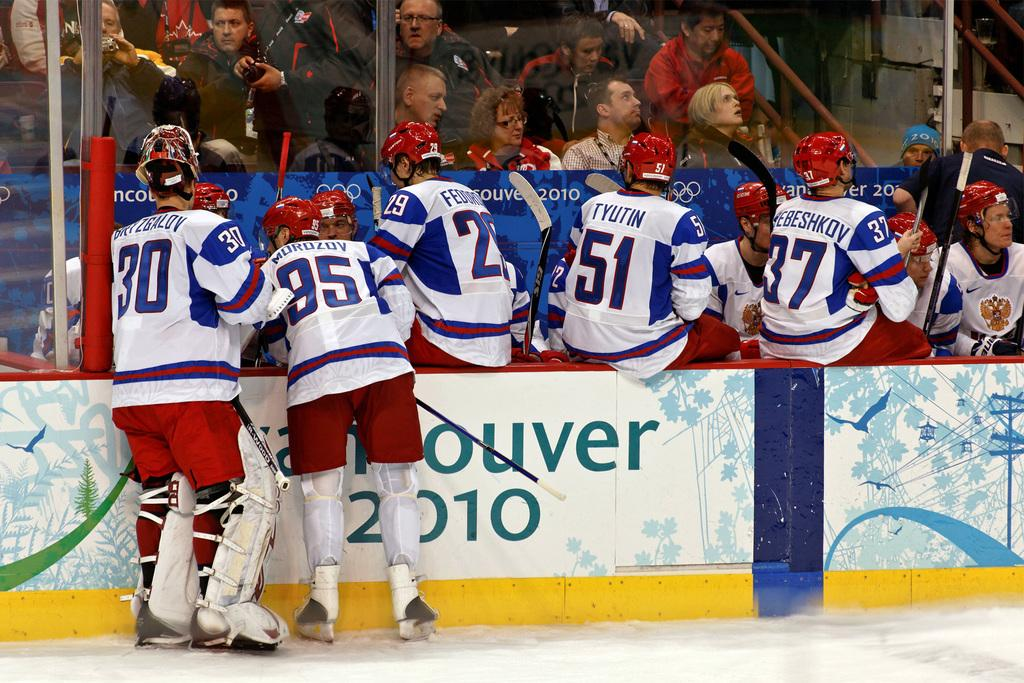<image>
Create a compact narrative representing the image presented. A group of hockey players is on the side at the Vancouver 2010 games with the crowd watching. 